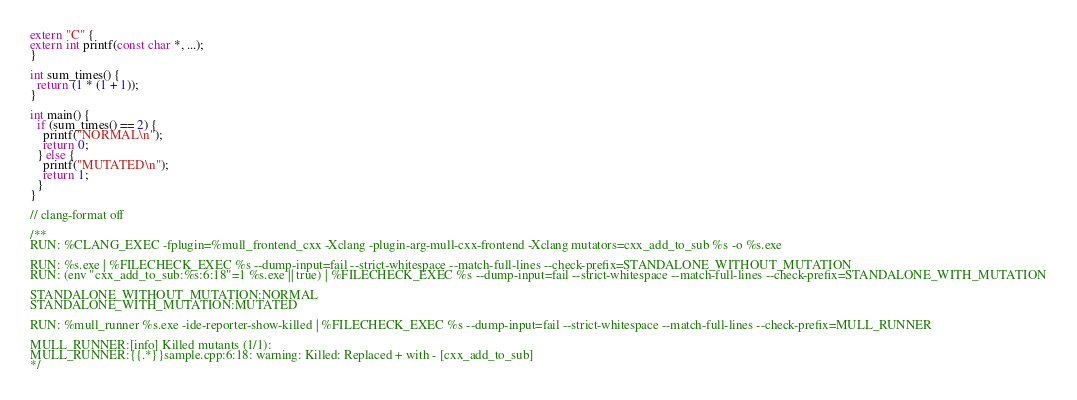Convert code to text. <code><loc_0><loc_0><loc_500><loc_500><_C++_>extern "C" {
extern int printf(const char *, ...);
}

int sum_times() {
  return (1 * (1 + 1));
}

int main() {
  if (sum_times() == 2) {
    printf("NORMAL\n");
    return 0;
  } else {
    printf("MUTATED\n");
    return 1;
  }
}

// clang-format off

/**
RUN: %CLANG_EXEC -fplugin=%mull_frontend_cxx -Xclang -plugin-arg-mull-cxx-frontend -Xclang mutators=cxx_add_to_sub %s -o %s.exe

RUN: %s.exe | %FILECHECK_EXEC %s --dump-input=fail --strict-whitespace --match-full-lines --check-prefix=STANDALONE_WITHOUT_MUTATION
RUN: (env "cxx_add_to_sub:%s:6:18"=1 %s.exe || true) | %FILECHECK_EXEC %s --dump-input=fail --strict-whitespace --match-full-lines --check-prefix=STANDALONE_WITH_MUTATION

STANDALONE_WITHOUT_MUTATION:NORMAL
STANDALONE_WITH_MUTATION:MUTATED

RUN: %mull_runner %s.exe -ide-reporter-show-killed | %FILECHECK_EXEC %s --dump-input=fail --strict-whitespace --match-full-lines --check-prefix=MULL_RUNNER

MULL_RUNNER:[info] Killed mutants (1/1):
MULL_RUNNER:{{.*}}sample.cpp:6:18: warning: Killed: Replaced + with - [cxx_add_to_sub]
*/
</code> 